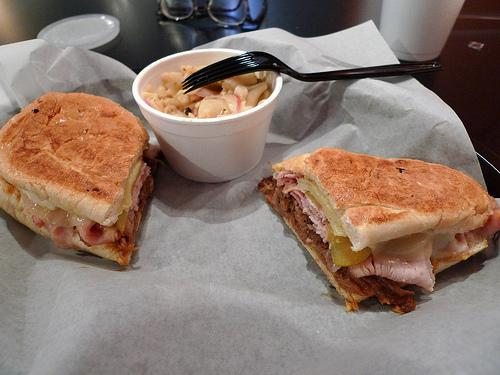Question: what food is in the picture?
Choices:
A. A salad.
B. A hot dog.
C. A hamburger.
D. Meat sandwich.
Answer with the letter. Answer: D Question: how many people are in the picture?
Choices:
A. None.
B. Two.
C. Six.
D. Too many to count.
Answer with the letter. Answer: A Question: what cup is there?
Choices:
A. Plastic.
B. Metal.
C. Glass.
D. Styrofoam.
Answer with the letter. Answer: D Question: how many halves of a sandwich are there?
Choices:
A. Two.
B. Four.
C. One.
D. Zero.
Answer with the letter. Answer: A 